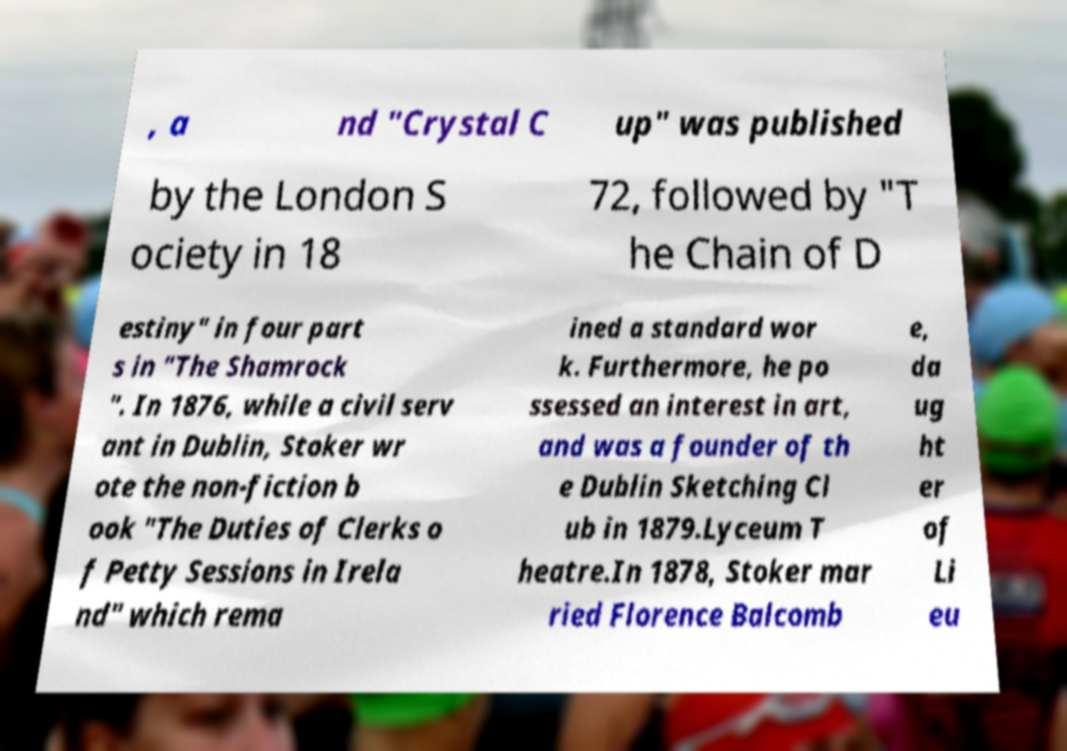Please read and relay the text visible in this image. What does it say? , a nd "Crystal C up" was published by the London S ociety in 18 72, followed by "T he Chain of D estiny" in four part s in "The Shamrock ". In 1876, while a civil serv ant in Dublin, Stoker wr ote the non-fiction b ook "The Duties of Clerks o f Petty Sessions in Irela nd" which rema ined a standard wor k. Furthermore, he po ssessed an interest in art, and was a founder of th e Dublin Sketching Cl ub in 1879.Lyceum T heatre.In 1878, Stoker mar ried Florence Balcomb e, da ug ht er of Li eu 